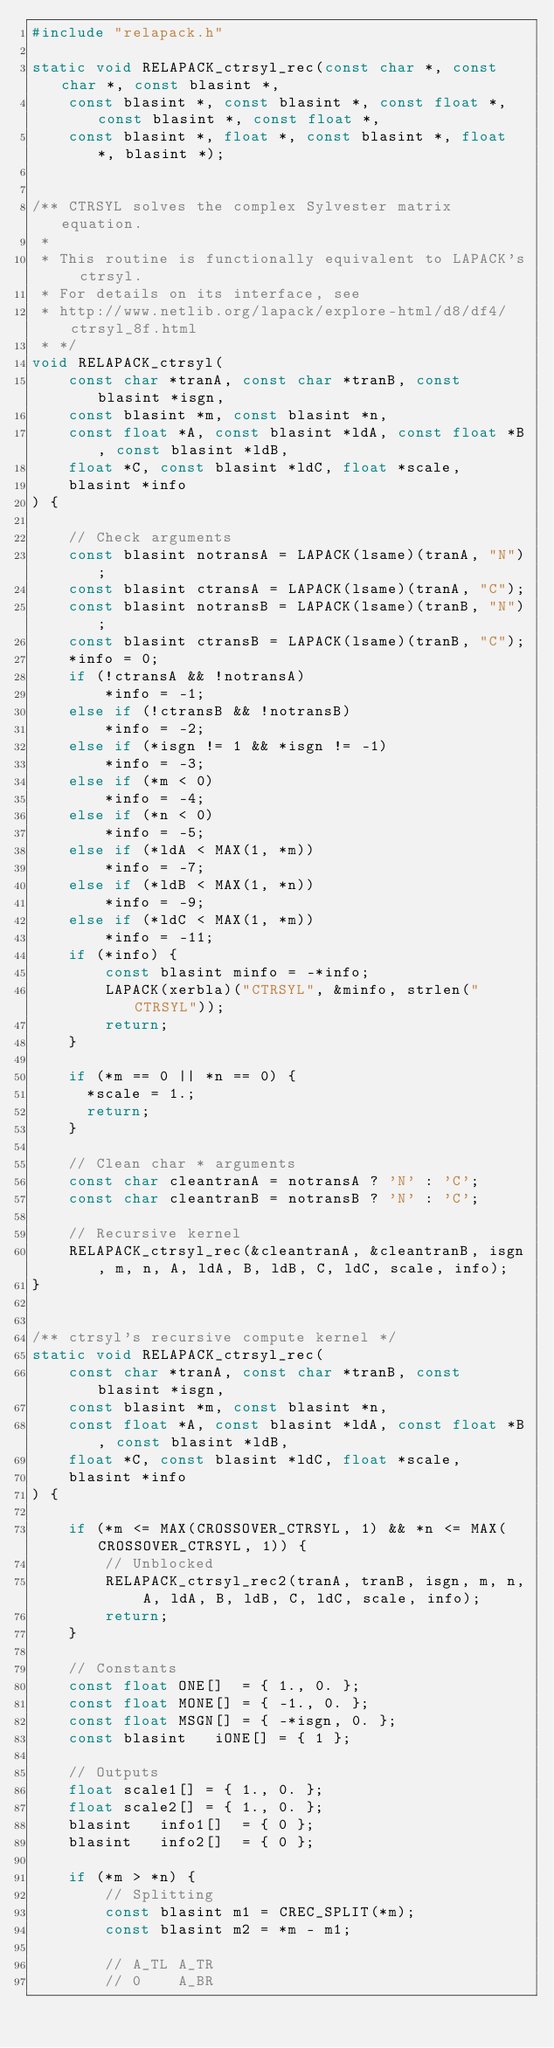Convert code to text. <code><loc_0><loc_0><loc_500><loc_500><_C_>#include "relapack.h"

static void RELAPACK_ctrsyl_rec(const char *, const char *, const blasint *,
    const blasint *, const blasint *, const float *, const blasint *, const float *,
    const blasint *, float *, const blasint *, float *, blasint *);


/** CTRSYL solves the complex Sylvester matrix equation.
 *
 * This routine is functionally equivalent to LAPACK's ctrsyl.
 * For details on its interface, see
 * http://www.netlib.org/lapack/explore-html/d8/df4/ctrsyl_8f.html
 * */
void RELAPACK_ctrsyl(
    const char *tranA, const char *tranB, const blasint *isgn,
    const blasint *m, const blasint *n,
    const float *A, const blasint *ldA, const float *B, const blasint *ldB,
    float *C, const blasint *ldC, float *scale,
    blasint *info
) {

    // Check arguments
    const blasint notransA = LAPACK(lsame)(tranA, "N");
    const blasint ctransA = LAPACK(lsame)(tranA, "C");
    const blasint notransB = LAPACK(lsame)(tranB, "N");
    const blasint ctransB = LAPACK(lsame)(tranB, "C");
    *info = 0;
    if (!ctransA && !notransA)
        *info = -1;
    else if (!ctransB && !notransB)
        *info = -2;
    else if (*isgn != 1 && *isgn != -1)
        *info = -3;
    else if (*m < 0)
        *info = -4;
    else if (*n < 0)
        *info = -5;
    else if (*ldA < MAX(1, *m))
        *info = -7;
    else if (*ldB < MAX(1, *n))
        *info = -9;
    else if (*ldC < MAX(1, *m))
        *info = -11;
    if (*info) {
        const blasint minfo = -*info;
        LAPACK(xerbla)("CTRSYL", &minfo, strlen("CTRSYL"));
        return;
    }

    if (*m == 0 || *n == 0) {
      *scale = 1.;
      return;
    }

    // Clean char * arguments
    const char cleantranA = notransA ? 'N' : 'C';
    const char cleantranB = notransB ? 'N' : 'C';

    // Recursive kernel
    RELAPACK_ctrsyl_rec(&cleantranA, &cleantranB, isgn, m, n, A, ldA, B, ldB, C, ldC, scale, info);
}


/** ctrsyl's recursive compute kernel */
static void RELAPACK_ctrsyl_rec(
    const char *tranA, const char *tranB, const blasint *isgn,
    const blasint *m, const blasint *n,
    const float *A, const blasint *ldA, const float *B, const blasint *ldB,
    float *C, const blasint *ldC, float *scale,
    blasint *info
) {

    if (*m <= MAX(CROSSOVER_CTRSYL, 1) && *n <= MAX(CROSSOVER_CTRSYL, 1)) {
        // Unblocked
        RELAPACK_ctrsyl_rec2(tranA, tranB, isgn, m, n, A, ldA, B, ldB, C, ldC, scale, info);
        return;
    }

    // Constants
    const float ONE[]  = { 1., 0. };
    const float MONE[] = { -1., 0. };
    const float MSGN[] = { -*isgn, 0. };
    const blasint   iONE[] = { 1 };

    // Outputs
    float scale1[] = { 1., 0. };
    float scale2[] = { 1., 0. };
    blasint   info1[]  = { 0 };
    blasint   info2[]  = { 0 };

    if (*m > *n) {
        // Splitting
        const blasint m1 = CREC_SPLIT(*m);
        const blasint m2 = *m - m1;

        // A_TL A_TR
        // 0    A_BR</code> 